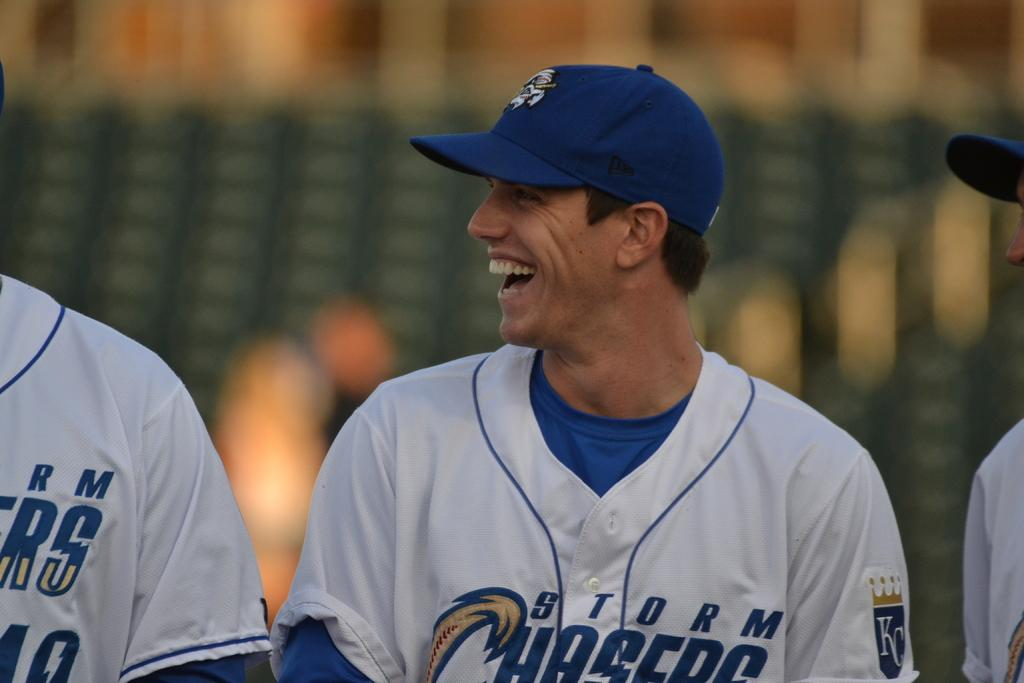<image>
Present a compact description of the photo's key features. A player is laughing to a team mate with KC written on his arm. 